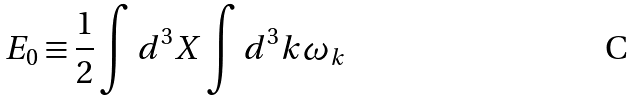<formula> <loc_0><loc_0><loc_500><loc_500>E _ { 0 } \equiv \frac { 1 } { 2 } \int d ^ { 3 } X \int d ^ { 3 } k \omega _ { k }</formula> 